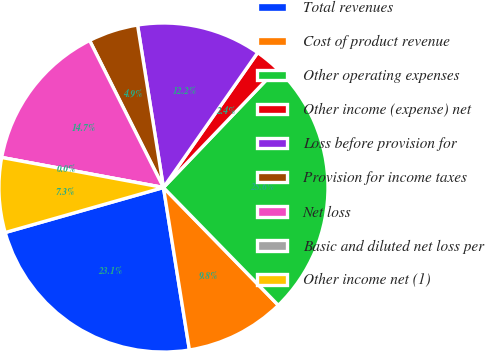Convert chart to OTSL. <chart><loc_0><loc_0><loc_500><loc_500><pie_chart><fcel>Total revenues<fcel>Cost of product revenue<fcel>Other operating expenses<fcel>Other income (expense) net<fcel>Loss before provision for<fcel>Provision for income taxes<fcel>Net loss<fcel>Basic and diluted net loss per<fcel>Other income net (1)<nl><fcel>23.11%<fcel>9.78%<fcel>25.55%<fcel>2.44%<fcel>12.22%<fcel>4.89%<fcel>14.67%<fcel>0.0%<fcel>7.33%<nl></chart> 